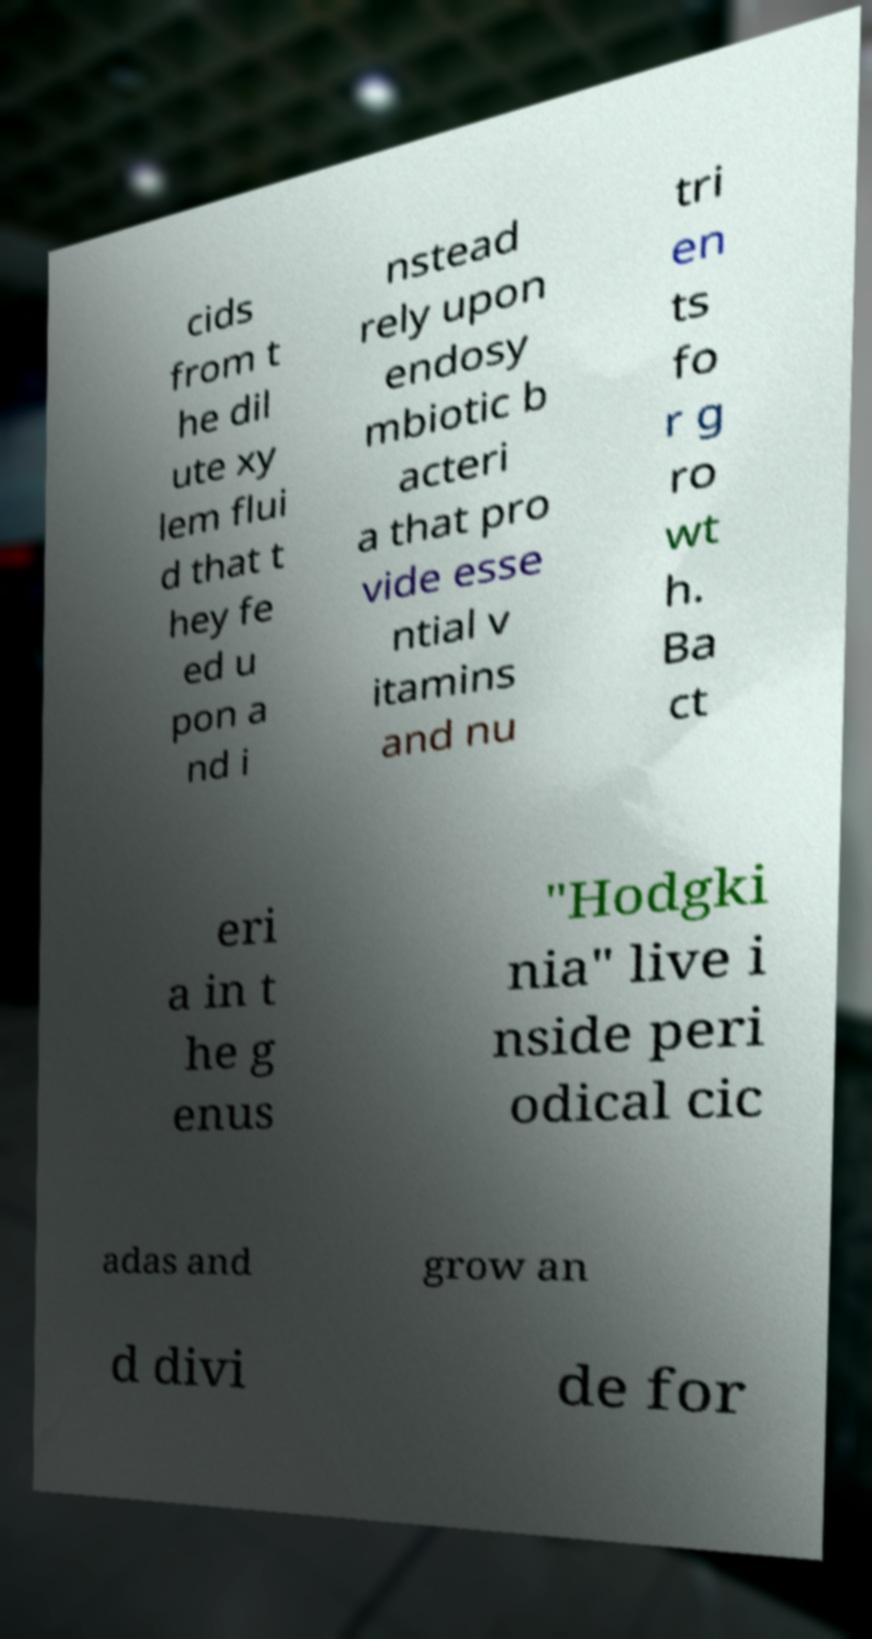Could you assist in decoding the text presented in this image and type it out clearly? cids from t he dil ute xy lem flui d that t hey fe ed u pon a nd i nstead rely upon endosy mbiotic b acteri a that pro vide esse ntial v itamins and nu tri en ts fo r g ro wt h. Ba ct eri a in t he g enus "Hodgki nia" live i nside peri odical cic adas and grow an d divi de for 